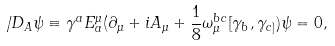<formula> <loc_0><loc_0><loc_500><loc_500>\not { \, D } _ { A } \psi \equiv \gamma ^ { a } E _ { a } ^ { \mu } ( \partial _ { \mu } + i A _ { \mu } + \frac { 1 } { 8 } \omega _ { \mu } ^ { b c } [ \gamma _ { b } , \gamma _ { c ] } ) \psi = 0 ,</formula> 